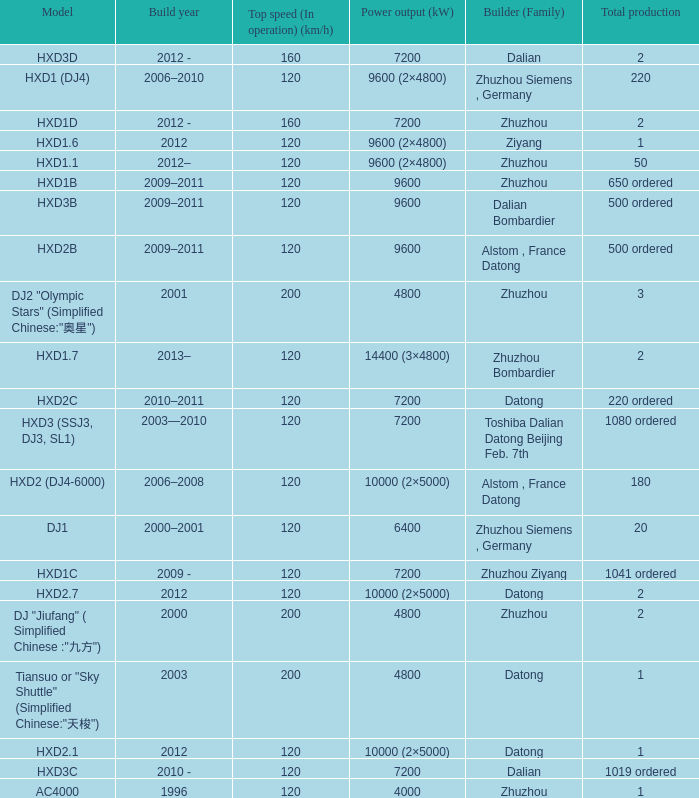What is the power output (kw) of builder zhuzhou, model hxd1d, with a total production of 2? 7200.0. 